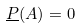Convert formula to latex. <formula><loc_0><loc_0><loc_500><loc_500>\underline { P } ( A ) = 0</formula> 